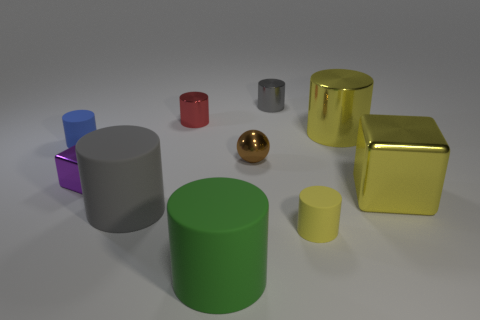Subtract all small matte cylinders. How many cylinders are left? 5 Subtract all yellow cylinders. How many cylinders are left? 5 Subtract all cubes. How many objects are left? 8 Subtract all green cubes. Subtract all purple spheres. How many cubes are left? 2 Subtract all cyan cylinders. How many yellow blocks are left? 1 Subtract all blue balls. Subtract all blue cylinders. How many objects are left? 9 Add 8 small gray cylinders. How many small gray cylinders are left? 9 Add 1 gray things. How many gray things exist? 3 Subtract 0 brown cylinders. How many objects are left? 10 Subtract 1 cylinders. How many cylinders are left? 6 